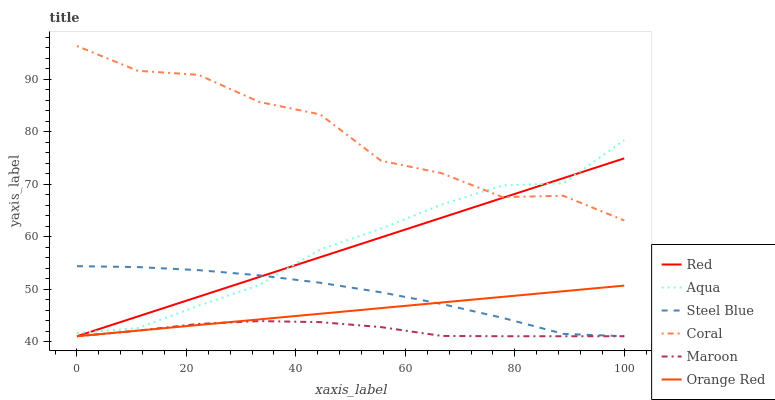Does Maroon have the minimum area under the curve?
Answer yes or no. Yes. Does Coral have the maximum area under the curve?
Answer yes or no. Yes. Does Aqua have the minimum area under the curve?
Answer yes or no. No. Does Aqua have the maximum area under the curve?
Answer yes or no. No. Is Orange Red the smoothest?
Answer yes or no. Yes. Is Coral the roughest?
Answer yes or no. Yes. Is Aqua the smoothest?
Answer yes or no. No. Is Aqua the roughest?
Answer yes or no. No. Does Steel Blue have the lowest value?
Answer yes or no. Yes. Does Aqua have the lowest value?
Answer yes or no. No. Does Coral have the highest value?
Answer yes or no. Yes. Does Aqua have the highest value?
Answer yes or no. No. Is Maroon less than Coral?
Answer yes or no. Yes. Is Coral greater than Orange Red?
Answer yes or no. Yes. Does Maroon intersect Orange Red?
Answer yes or no. Yes. Is Maroon less than Orange Red?
Answer yes or no. No. Is Maroon greater than Orange Red?
Answer yes or no. No. Does Maroon intersect Coral?
Answer yes or no. No. 